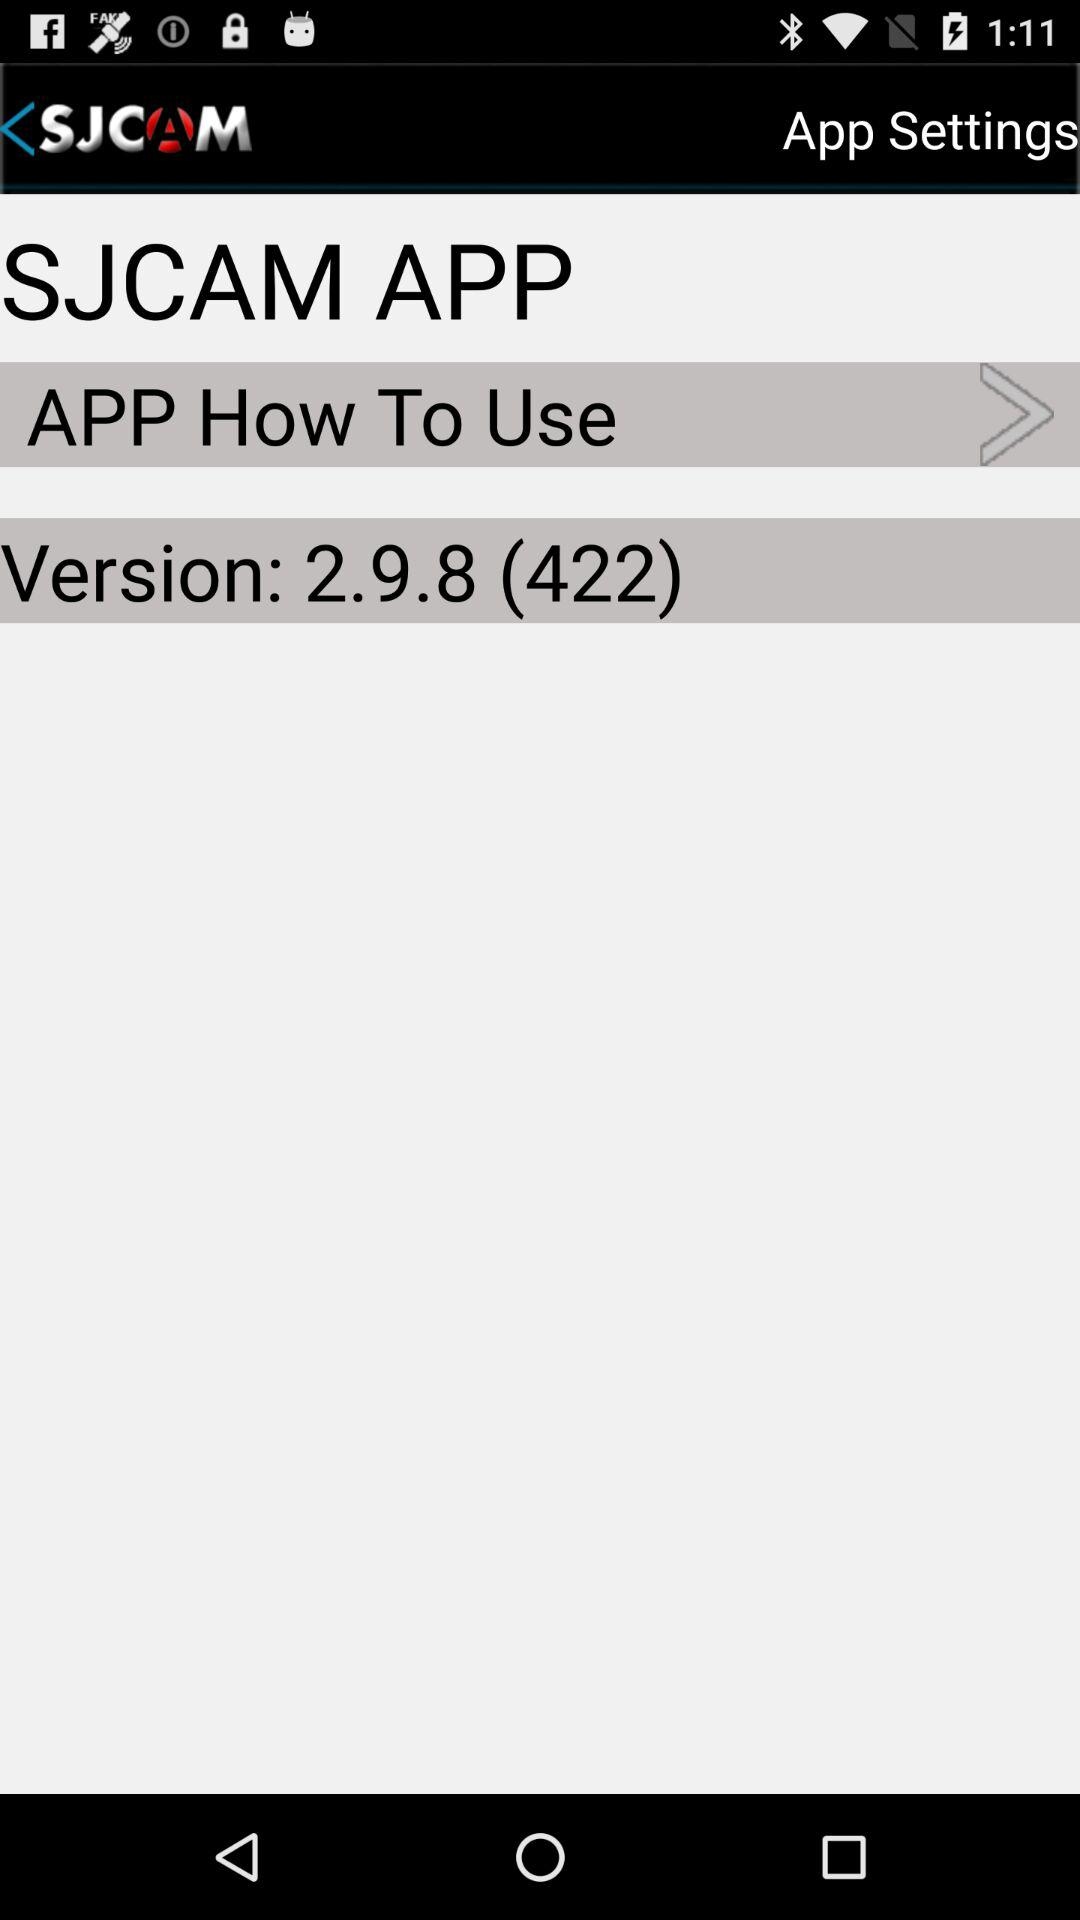What is the app's name? The app's name is "SJCAM APP". 